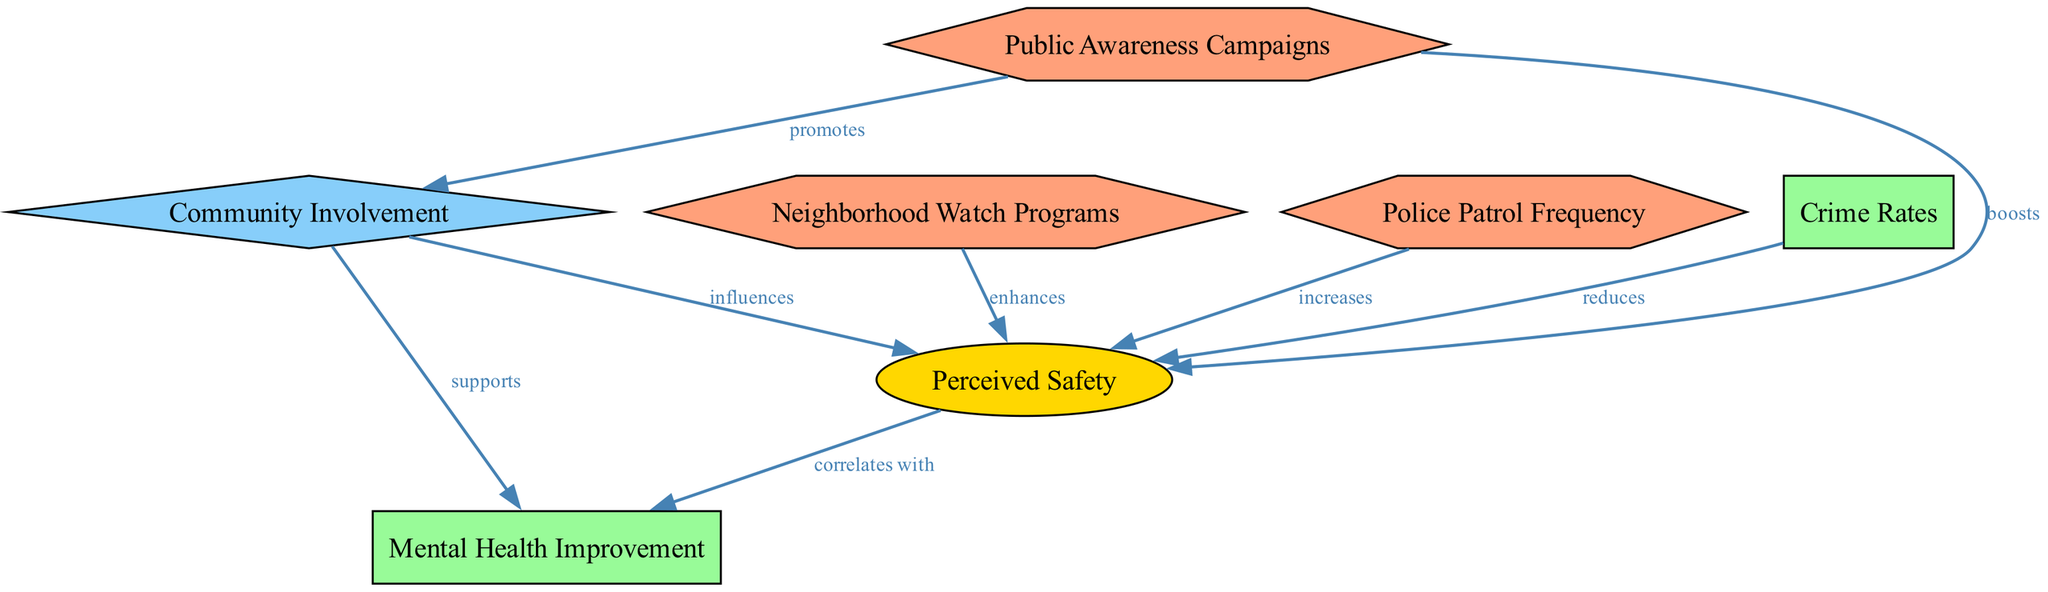What is the total number of nodes in the diagram? The diagram contains a total of 7 nodes as listed, which include factors, outcomes, intermediate factors, and interventions. Each node is unique and represented in the diagram.
Answer: 7 What type of relationship exists between "Perceived Safety" and "Mental Health Improvement"? The relationship is labeled as "correlates with," indicating a direct correlation between the two nodes. This suggests that as the level of perceived safety increases, mental health improvement is also noticed.
Answer: correlates with Which intervention influences "Perceived Safety" the most? "Neighborhood Watch Programs" enhances perceived safety according to the diagram. Interventions can have varying degrees of influence, but this one is specifically noted as enhancing safety.
Answer: enhances What is the role of "Community Involvement" in the diagram? "Community Involvement" serves as an intermediate factor that influences "Perceived Safety" and supports "Mental Health Improvement." It acts as a bridge affecting both perceived safety and mental health outcomes.
Answer: intermediate factor How does "Public Awareness Campaigns" impact "Mental Health Improvement"? "Public Awareness Campaigns" supports "Community Involvement," which in turn influences "Mental Health Improvement." The diagram shows that through promoting community involvement, awareness campaigns indirectly contribute to mental health improvement.
Answer: supports What effect do "Crime Rates" have on "Perceived Safety"? The edge connecting "Crime Rates" to "Perceived Safety" indicates that lower crime rates reduce perceptions of safety in the community. Thus, a decrease in crime rates directly uplifts the community's sense of safety.
Answer: reduces Which intervention is connected directly to "Public Awareness Campaigns"? The only intervention connected directly to "Public Awareness Campaigns" is "Community Involvement." The diagram specifies this relationship as promoting community engagement, which is critical for improving safety perception and mental health.
Answer: Community Involvement What is the influence of "Police Patrol Frequency" on "Perceived Safety"? "Police Patrol Frequency" increases "Perceived Safety," as depicted by the directed edge in the diagram. This suggests a positive relationship, where more frequent police patrols lead to heightened feelings of safety among residents.
Answer: increases How does "Community Involvement" relate to "Mental Health Improvement"? "Community Involvement" supports "Mental Health Improvement," establishing a conceptual link where increased community engagement contributes to better mental health outcomes for individuals within the community.
Answer: supports 